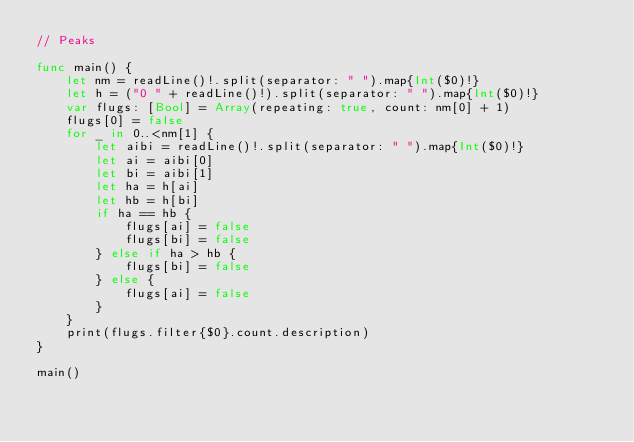Convert code to text. <code><loc_0><loc_0><loc_500><loc_500><_Swift_>// Peaks

func main() {
    let nm = readLine()!.split(separator: " ").map{Int($0)!}
    let h = ("0 " + readLine()!).split(separator: " ").map{Int($0)!}
    var flugs: [Bool] = Array(repeating: true, count: nm[0] + 1)
    flugs[0] = false
    for _ in 0..<nm[1] {
        let aibi = readLine()!.split(separator: " ").map{Int($0)!}
        let ai = aibi[0]
        let bi = aibi[1]
        let ha = h[ai]
        let hb = h[bi]
        if ha == hb {
            flugs[ai] = false
            flugs[bi] = false
        } else if ha > hb {
            flugs[bi] = false
        } else {
            flugs[ai] = false
        }
    }
    print(flugs.filter{$0}.count.description)
}

main()</code> 